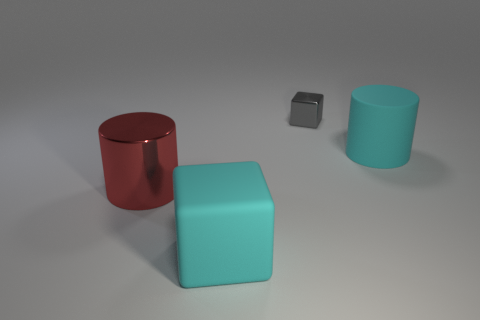How many cylinders are either red things or metallic things?
Give a very brief answer. 1. Is the color of the metal thing that is in front of the rubber cylinder the same as the small metallic object?
Your answer should be compact. No. What material is the large cyan thing that is on the left side of the object that is to the right of the metal object that is to the right of the red shiny cylinder?
Ensure brevity in your answer.  Rubber. Is the size of the red metal cylinder the same as the gray metal object?
Your answer should be very brief. No. Does the large rubber cube have the same color as the metallic cylinder to the left of the tiny gray object?
Ensure brevity in your answer.  No. There is a big cyan object that is the same material as the big cyan block; what is its shape?
Your answer should be compact. Cylinder. Do the cyan matte object that is in front of the big shiny object and the small gray object have the same shape?
Provide a short and direct response. Yes. What is the size of the metallic object behind the big rubber thing to the right of the big matte block?
Your answer should be very brief. Small. There is a small block that is the same material as the red cylinder; what is its color?
Provide a succinct answer. Gray. What number of things have the same size as the cyan rubber cylinder?
Make the answer very short. 2. 